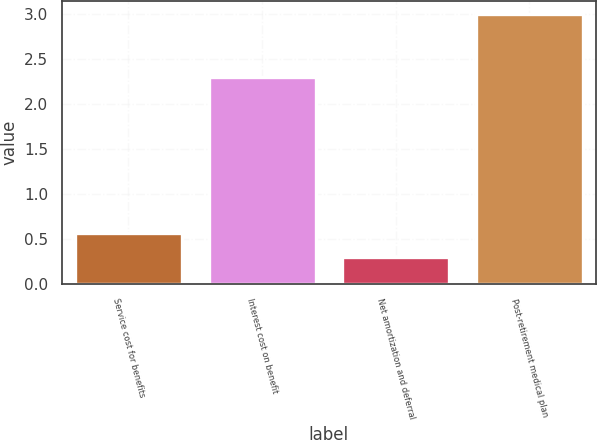<chart> <loc_0><loc_0><loc_500><loc_500><bar_chart><fcel>Service cost for benefits<fcel>Interest cost on benefit<fcel>Net amortization and deferral<fcel>Post-retirement medical plan<nl><fcel>0.57<fcel>2.3<fcel>0.3<fcel>3<nl></chart> 